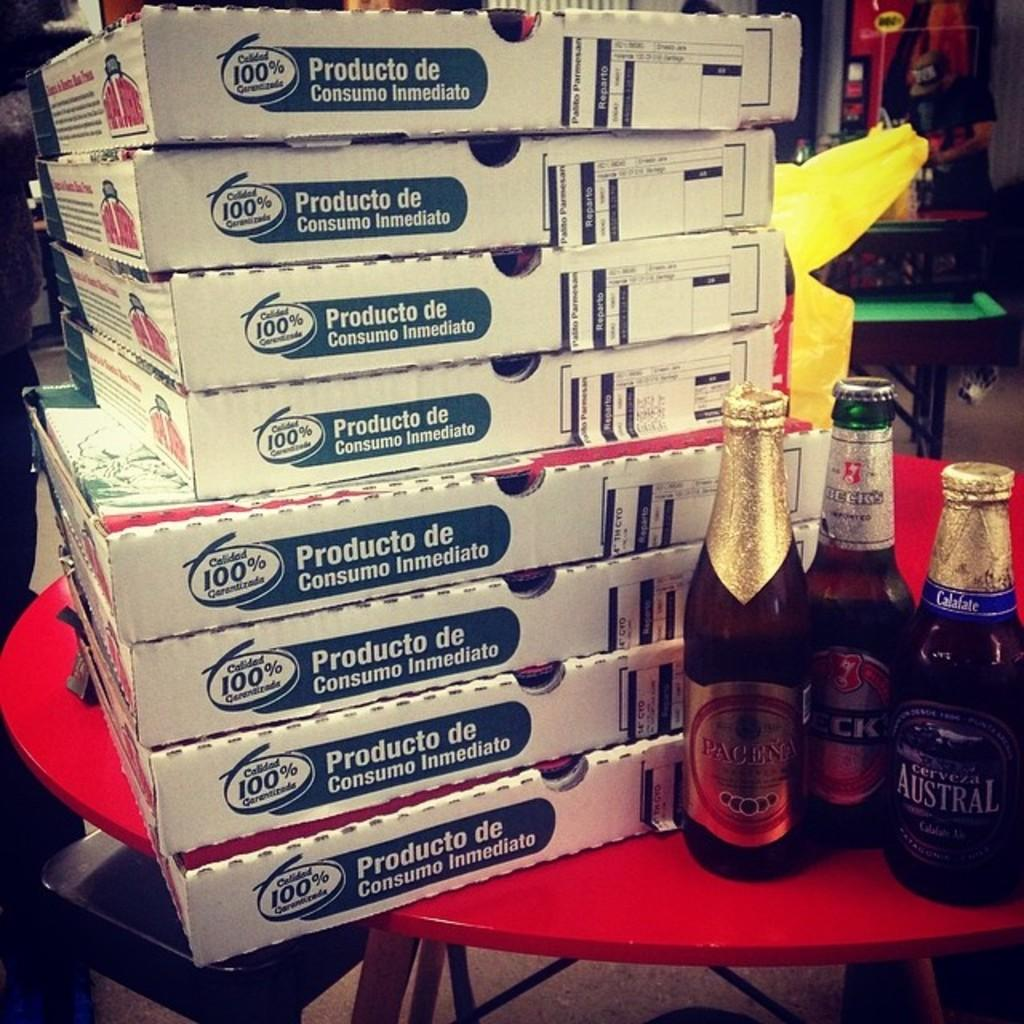Provide a one-sentence caption for the provided image. Several boxes sit on a table besdie beer bottles Pacena, Becks and Austral. 